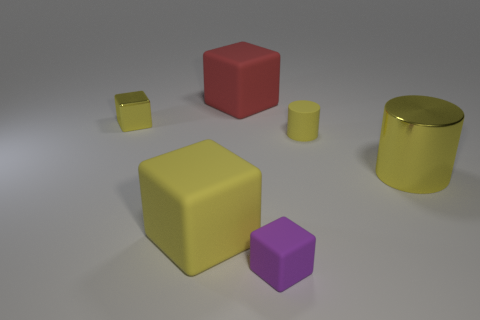Subtract all yellow blocks. How many were subtracted if there are1yellow blocks left? 1 Subtract 1 cubes. How many cubes are left? 3 Subtract all yellow cubes. Subtract all cyan spheres. How many cubes are left? 2 Add 4 gray rubber cubes. How many objects exist? 10 Subtract all cylinders. How many objects are left? 4 Add 3 small yellow metallic things. How many small yellow metallic things exist? 4 Subtract 0 red cylinders. How many objects are left? 6 Subtract all large cylinders. Subtract all small red metal objects. How many objects are left? 5 Add 3 red blocks. How many red blocks are left? 4 